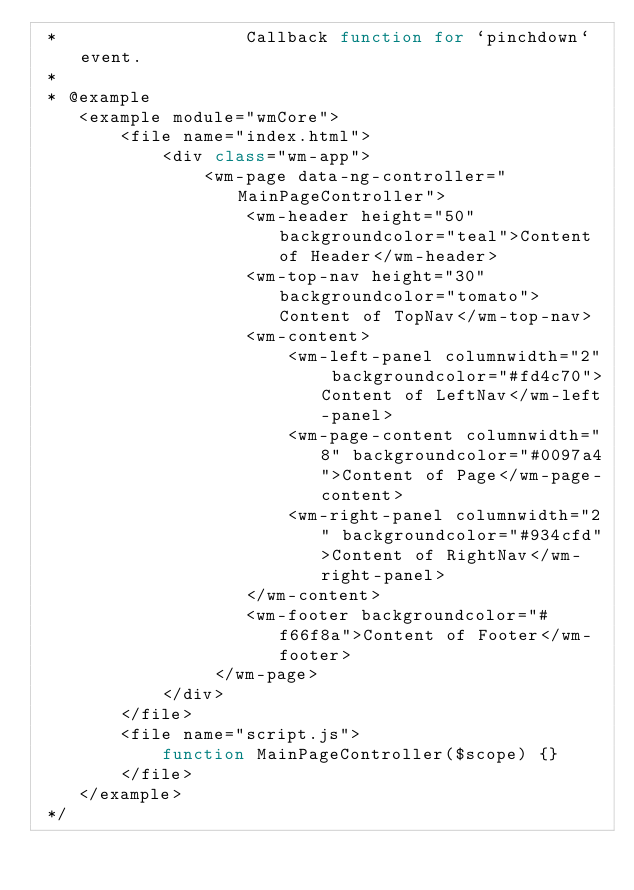Convert code to text. <code><loc_0><loc_0><loc_500><loc_500><_JavaScript_> *                  Callback function for `pinchdown` event.
 *
 * @example
    <example module="wmCore">
        <file name="index.html">
            <div class="wm-app">
                <wm-page data-ng-controller="MainPageController">
                    <wm-header height="50" backgroundcolor="teal">Content of Header</wm-header>
                    <wm-top-nav height="30" backgroundcolor="tomato">Content of TopNav</wm-top-nav>
                    <wm-content>
                        <wm-left-panel columnwidth="2" backgroundcolor="#fd4c70">Content of LeftNav</wm-left-panel>
                        <wm-page-content columnwidth="8" backgroundcolor="#0097a4">Content of Page</wm-page-content>
                        <wm-right-panel columnwidth="2" backgroundcolor="#934cfd">Content of RightNav</wm-right-panel>
                    </wm-content>
                    <wm-footer backgroundcolor="#f66f8a">Content of Footer</wm-footer>
                 </wm-page>
            </div>
        </file>
        <file name="script.js">
            function MainPageController($scope) {}
        </file>
    </example>
 */
</code> 